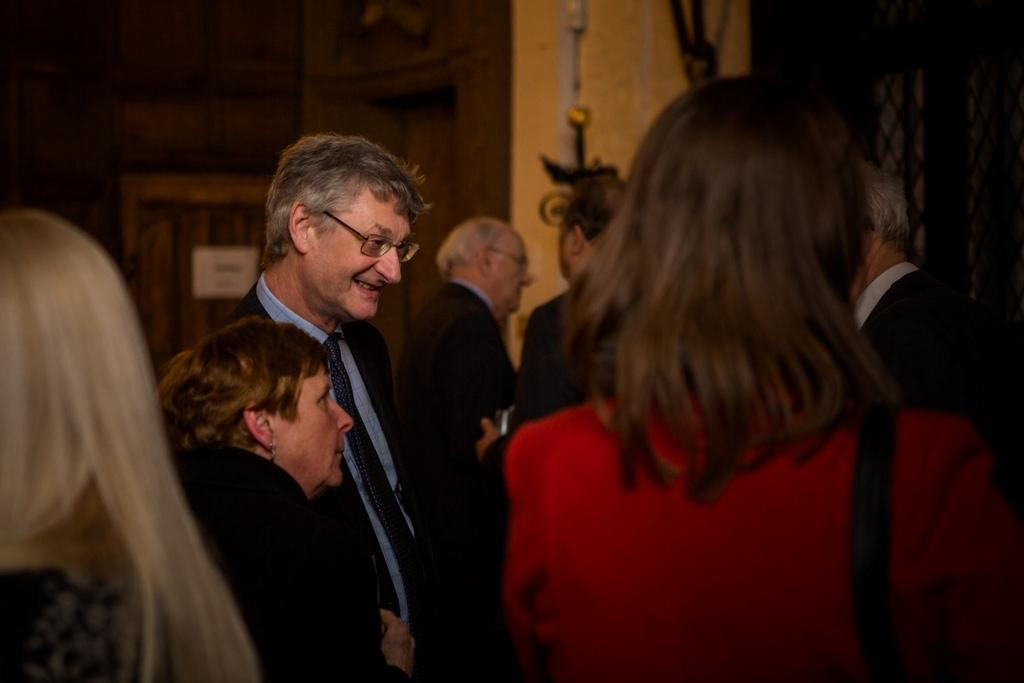How many people are in the image? There is a group of people in the image, but the exact number cannot be determined without more information. What can be seen in the background of the image? There are objects visible in the background of the image, but their specific nature cannot be determined without more information. What type of coil is being used by the animals at the zoo in the image? There is no mention of a zoo or animals in the image, and therefore no coil can be observed. 